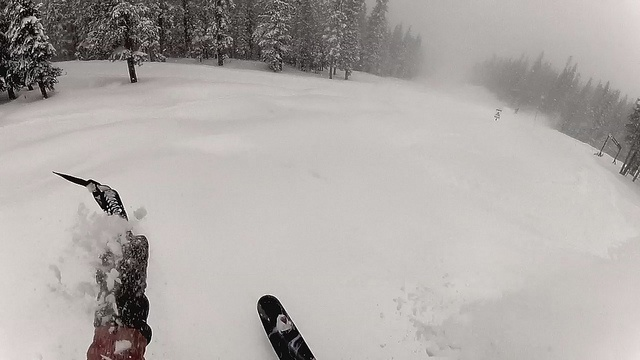Describe the objects in this image and their specific colors. I can see people in black, gray, darkgray, and maroon tones and snowboard in black, gray, darkgray, and lightgray tones in this image. 